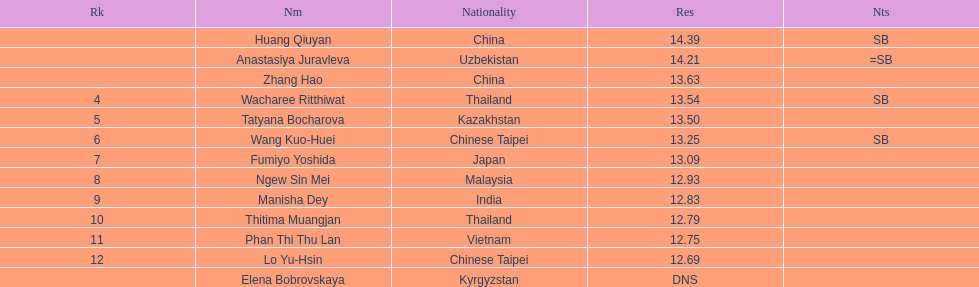Which country came in first? China. 